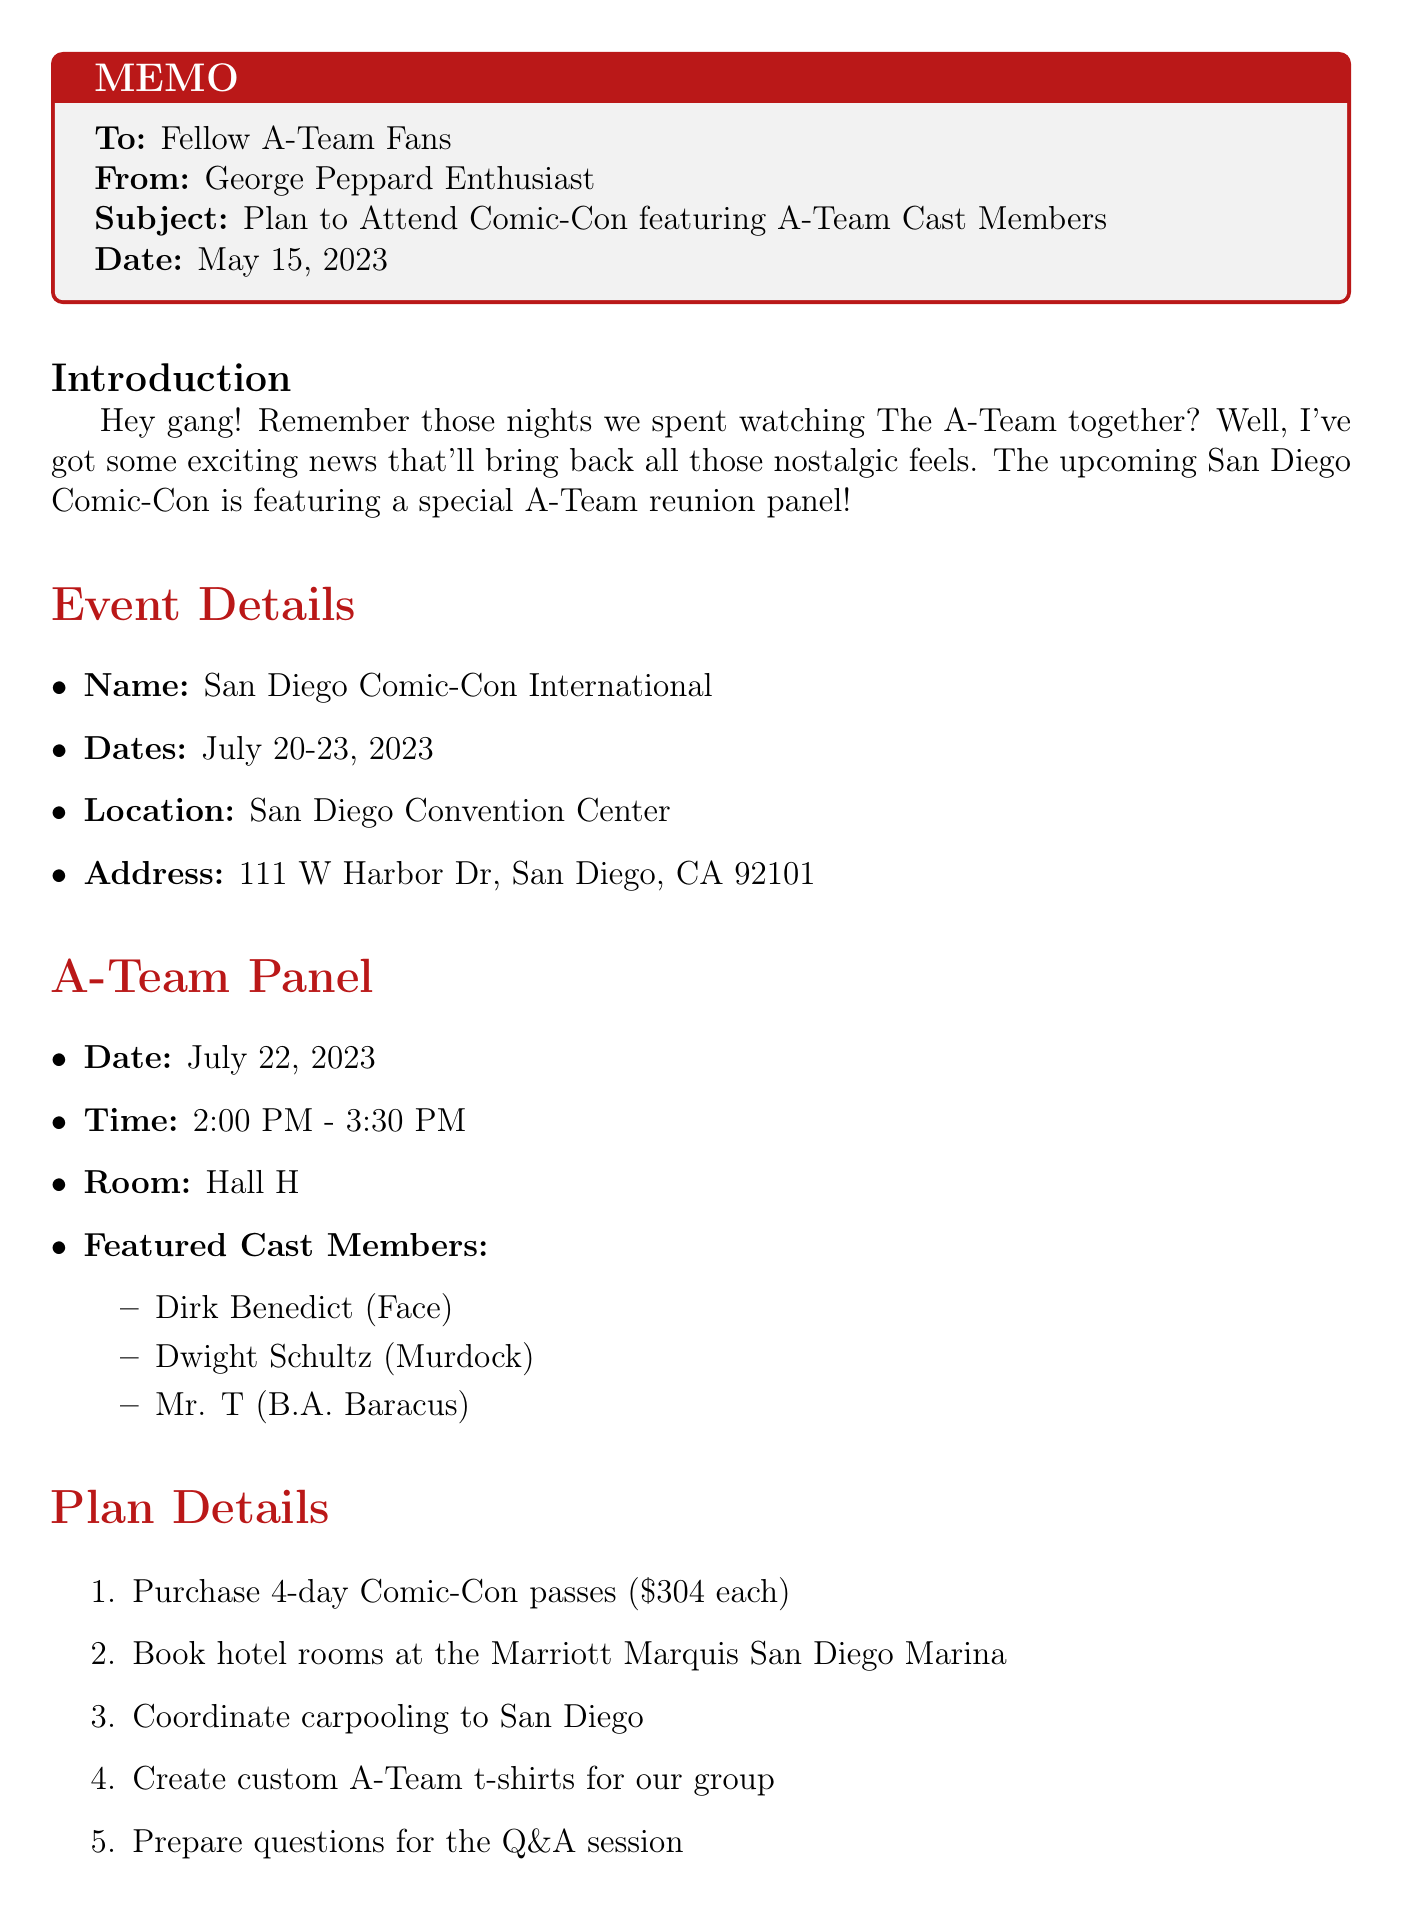What are the dates of the Comic-Con? The dates of the Comic-Con are listed in the event details section of the document.
Answer: July 20-23, 2023 Who are the featured cast members at the A-Team panel? The featured cast members are mentioned under the A-Team Panel section.
Answer: Dirk Benedict, Dwight Schultz, Mr. T What is the total budget estimate for the trip? The total budget estimate is found in the budget estimate section of the document.
Answer: $3,916 What is the purpose of creating custom t-shirts? The purpose of creating custom t-shirts is outlined in the plan details section for the group activity.
Answer: Custom A-Team t-shirts for our group When is the A-Team panel scheduled? The date and time of the A-Team panel are specified in the A-Team Panel section.
Answer: July 22, 2023, 2:00 PM - 3:30 PM What hotel is recommended for booking accommodations? The recommended hotel for accommodations is listed in the plan details section for the trip.
Answer: Marriott Marquis San Diego Marina What is one of the additional activities mentioned? The additional activities are outlined in their own section, listing various fun options during the convention.
Answer: Visit the A-Team merchandise booth What is the address of the San Diego Convention Center? The address of the convention center is provided in the event details section.
Answer: 111 W Harbor Dr, San Diego, CA 92101 